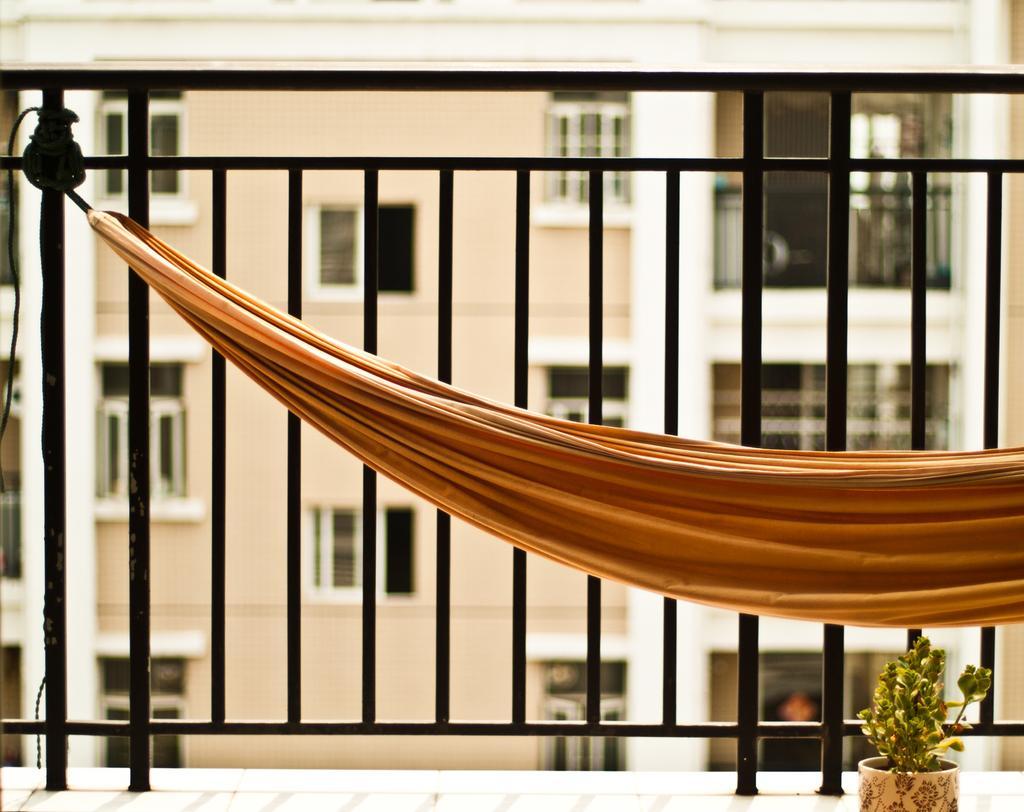How would you summarize this image in a sentence or two? In this image there is a railing. There is a cloth tied to the railing with a help of a rope. In the bottom right there is a houseplant. Behind the railing there is a building. There are glass windows and railings to the building. 